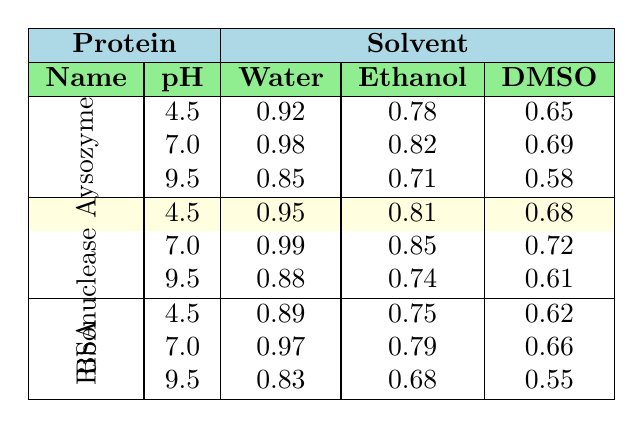What is the stability score of Lysozyme in Water at pH 7.0? Referring to the table, for Lysozyme under the column for Water and row for pH 7.0, the stability score is 0.98.
Answer: 0.98 What is the highest stability score of Ribonuclease A in DMSO? Looking at the table, the stability scores for Ribonuclease A in DMSO at each pH level are 0.68 (pH 4.5), 0.72 (pH 7.0), and 0.61 (pH 9.5). The highest is 0.72 at pH 7.0.
Answer: 0.72 Which solvent provides the lowest stability score for Bovine Serum Albumin? Reviewing the table, the stability scores for Bovine Serum Albumin in Water, Ethanol, and DMSO at all pH levels show that DMSO at pH 9.5 has the lowest score of 0.55.
Answer: DMSO What is the average stability score of Lysozyme across all tested solvents at pH 4.5? For Lysozyme at pH 4.5, the stability scores are 0.92 (Water), 0.78 (Ethanol), and 0.65 (DMSO). The average score is calculated as (0.92 + 0.78 + 0.65) / 3 = 2.35 / 3 = 0.7833.
Answer: 0.78 Does Ethanol provide better stability for Ribonuclease A than DMSO at pH 9.5? Checking the table, Ribonuclease A in Ethanol at pH 9.5 has a stability score of 0.74 while in DMSO it is 0.61. Since 0.74 is greater than 0.61, the answer is yes.
Answer: Yes What is the difference in stability scores of Bovine Serum Albumin between Water and Ethanol at pH 7.0? The stability score for Bovine Serum Albumin in Water at pH 7.0 is 0.97, and in Ethanol, it is 0.79. The difference is 0.97 - 0.79 = 0.18.
Answer: 0.18 Which protein has the highest stability score in Water at pH 7.0? The table shows that Ribonuclease A has the highest stability score of 0.99 in Water at pH 7.0 compared to Lysozyme and Bovine Serum Albumin, which have 0.98 and 0.97 respectively.
Answer: Ribonuclease A What is the trend in stability scores for Lysozyme across increasing pH levels in DMSO? The stability scores for Lysozyme in DMSO at pH 4.5, 7.0, and 9.5 are 0.65, 0.69, and 0.58 respectively. The trend shows an initial increase from 0.65 to 0.69 followed by a decrease to 0.58.
Answer: Increase then decrease What solvent maintains the highest stability score for all proteins at pH 7.0? Analyzing the table at pH 7.0, for Water the scores are 0.98 (Lysozyme), 0.99 (Ribonuclease A), and 0.97 (BSA); for Ethanol the scores are 0.82 (Lysozyme), 0.85 (Ribonuclease A), and 0.79 (BSA); for DMSO, the scores are 0.69 (Lysozyme), 0.72 (Ribonuclease A), and 0.66 (BSA). Water has the highest score of 0.99 for Ribonuclease A.
Answer: Water Is the stability score of Lysozyme in DMSO at pH 9.5 significantly lower than in Water at the same pH? The stability score for Lysozyme in DMSO at pH 9.5 is 0.58, whereas in Water it is 0.85. The difference of 0.27 indicates that DMSO provides significantly lower stability.
Answer: Yes What is the combined stability score for Ribonuclease A in Water and Ethanol at pH 4.5? For Ribonuclease A at pH 4.5, the stability scores are 0.95 (Water) and 0.81 (Ethanol). Summing these gives 0.95 + 0.81 = 1.76.
Answer: 1.76 